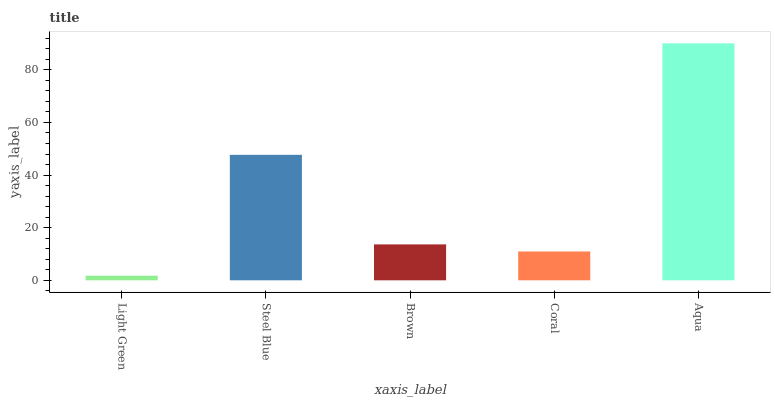Is Light Green the minimum?
Answer yes or no. Yes. Is Aqua the maximum?
Answer yes or no. Yes. Is Steel Blue the minimum?
Answer yes or no. No. Is Steel Blue the maximum?
Answer yes or no. No. Is Steel Blue greater than Light Green?
Answer yes or no. Yes. Is Light Green less than Steel Blue?
Answer yes or no. Yes. Is Light Green greater than Steel Blue?
Answer yes or no. No. Is Steel Blue less than Light Green?
Answer yes or no. No. Is Brown the high median?
Answer yes or no. Yes. Is Brown the low median?
Answer yes or no. Yes. Is Coral the high median?
Answer yes or no. No. Is Aqua the low median?
Answer yes or no. No. 